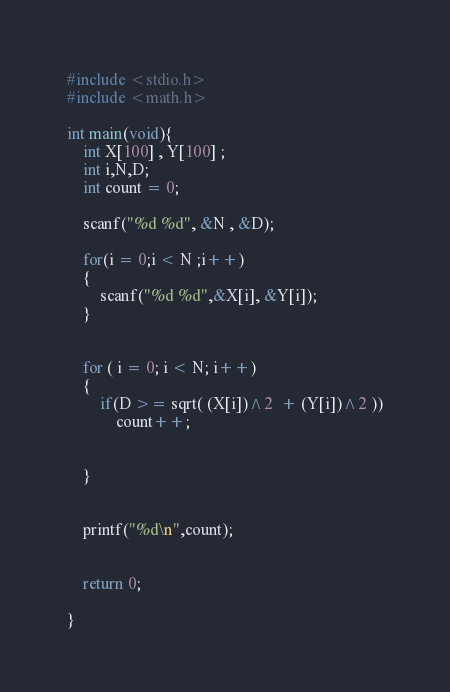Convert code to text. <code><loc_0><loc_0><loc_500><loc_500><_C_>#include <stdio.h>
#include <math.h>

int main(void){
    int X[100] , Y[100] ;
    int i,N,D;
    int count = 0;

    scanf("%d %d", &N , &D);

    for(i = 0;i < N ;i++)
    {
        scanf("%d %d",&X[i], &Y[i]);
    }


    for ( i = 0; i < N; i++)
    {        
        if(D >= sqrt( (X[i])^2  + (Y[i])^2 ))
            count++;
            
            
    }
    

    printf("%d\n",count);


    return 0;
    
}</code> 